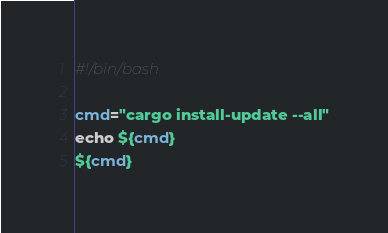<code> <loc_0><loc_0><loc_500><loc_500><_Bash_>#!/bin/bash

cmd="cargo install-update --all"
echo ${cmd}
${cmd}

</code> 